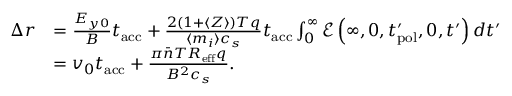Convert formula to latex. <formula><loc_0><loc_0><loc_500><loc_500>\begin{array} { r l } { \Delta r } & { = \frac { E _ { y 0 } } { B } t _ { a c c } + \frac { 2 ( 1 + \langle Z \rangle ) T q } { \langle m _ { i } \rangle c _ { s } } t _ { a c c } \int _ { 0 } ^ { \infty } \mathcal { E } \left ( \infty , 0 , t _ { p o l } ^ { \prime } , 0 , t ^ { \prime } \right ) d t ^ { \prime } } \\ & { = v _ { 0 } t _ { a c c } + \frac { \pi \bar { n } T R _ { e f f } q } { B ^ { 2 } c _ { s } } . } \end{array}</formula> 